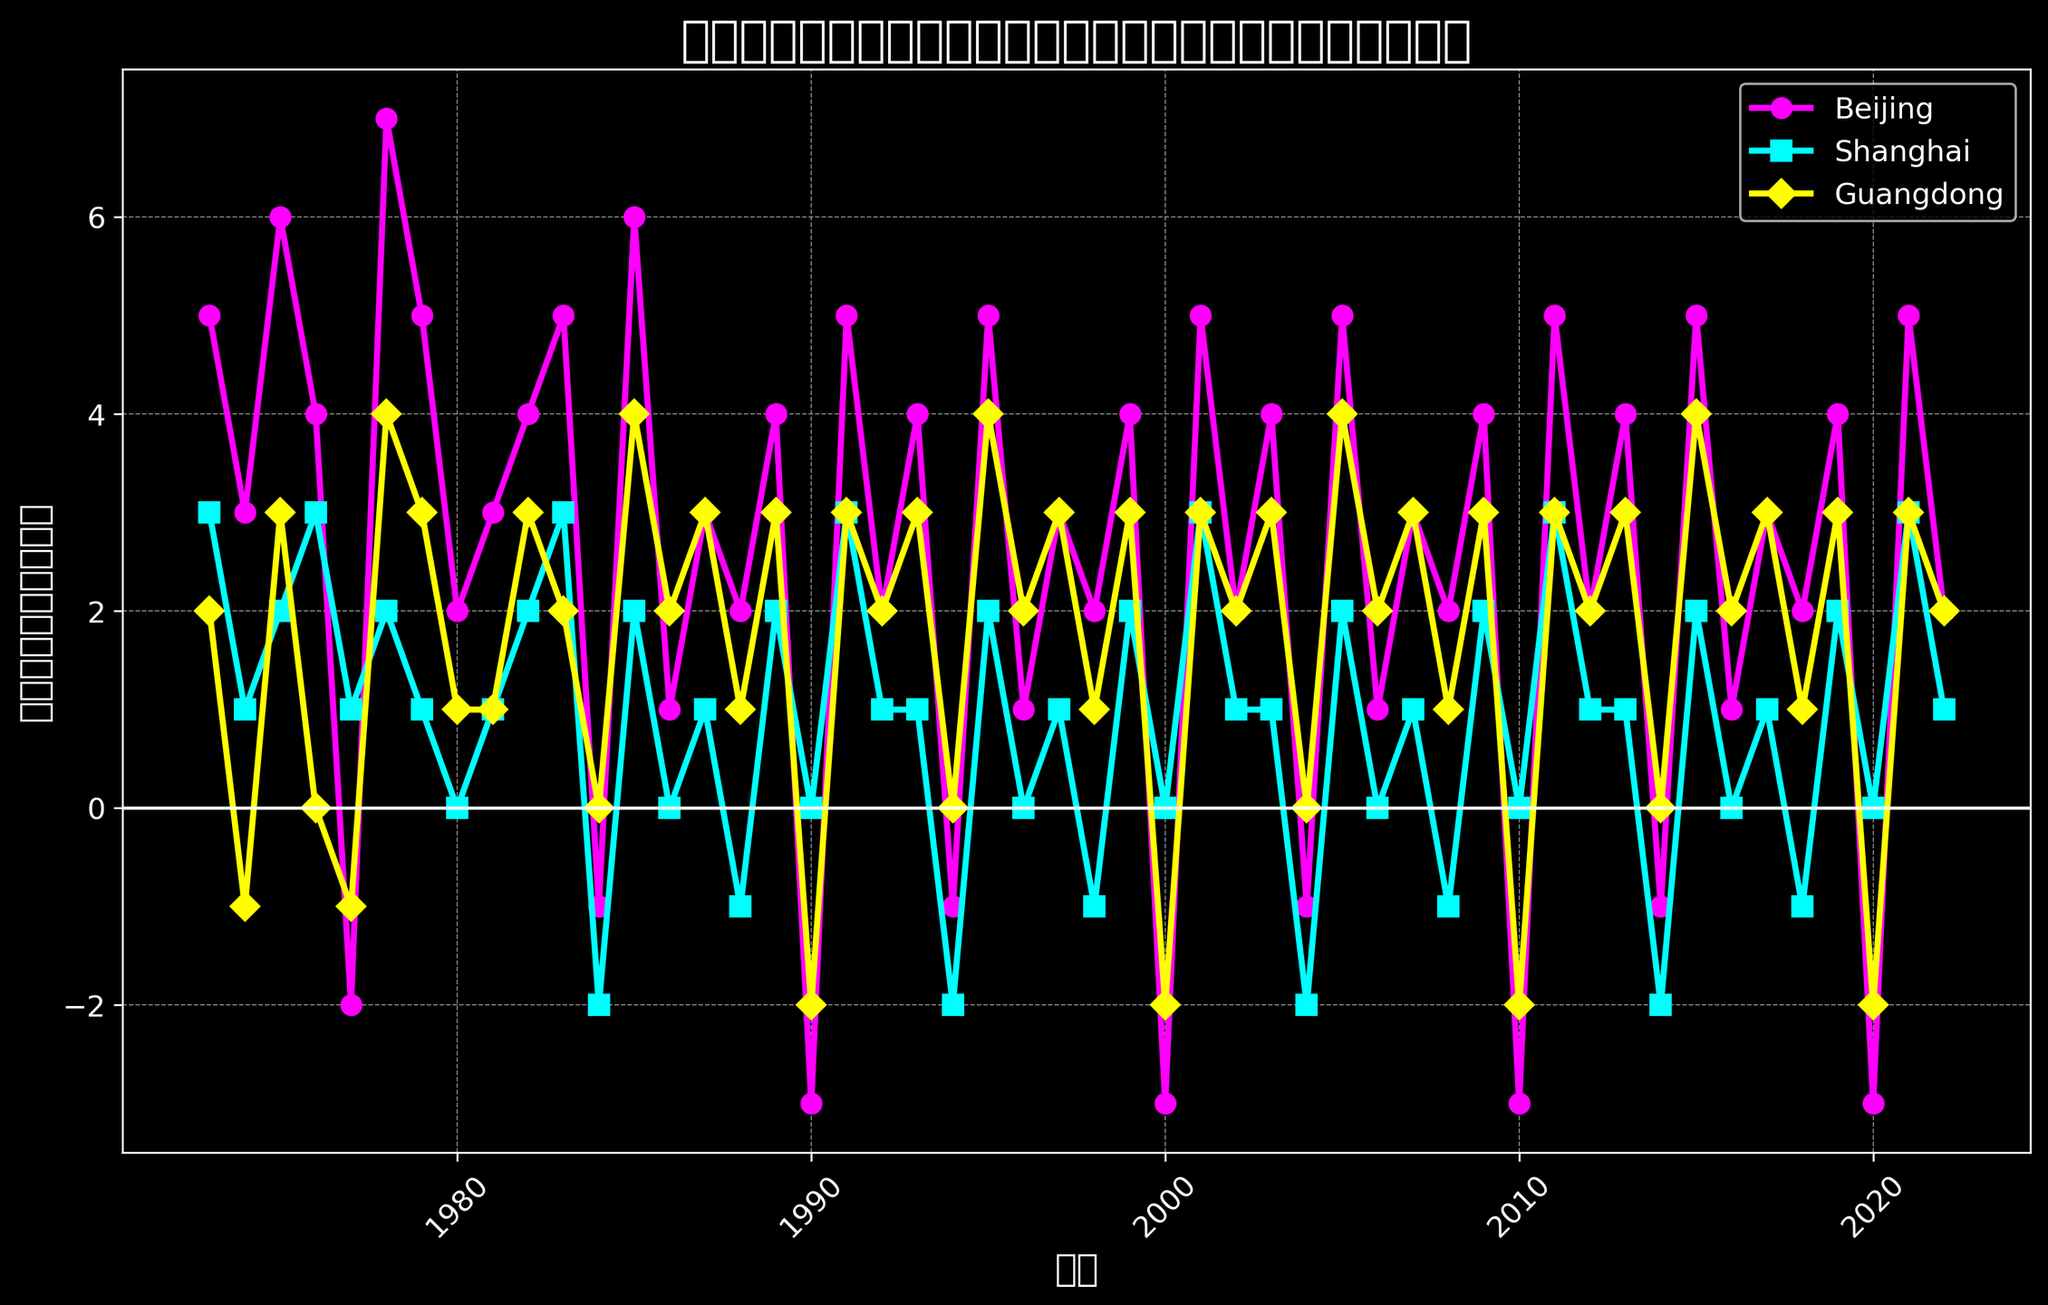What was the trend of research paper publications in Beijing during the 1980s? The trend can be determined by looking at the data points for Beijing during the 1980s. It shows fluctuations, with both dips and rises. Starting with a high value in 1981, there's a drop around mid-1980s, and another significant drop in 1990 before recovering again.
Answer: Fluctuating, with notable drops around mid-1980s and in 1990 Which province had the most stable number of research paper publications in the last decade? To determine stability, analyze the fluctuations in each province's data for the last decade (2013-2022). Beijing and Guangdong showed fluctuations, but Shanghai had the smallest changes in publication numbers over these years.
Answer: Shanghai During which year did all three provinces experience either zero or negative changes in research paper publications? By observing the points where all three lines are either at or below zero, check the data points for each year. The year 2010 shows all three provinces having zero or negative changes (Beijing: -3, Shanghai: 0, Guangdong: -2).
Answer: 2010 In which year did Beijing show the largest increase in research paper publications compared to the previous year? To find the year with the largest increase, look for the steepest upward slope in Beijing's line. The year 1978 to 1979 shows an increase from -2 in 1977 to 7 in 1978 and then 5 in 1979, indicating a steep rise.
Answer: 1977 to 1978 What are the colors used to represent each province, and what does each color signify? By looking at the legend or the colors of the lines in the figure, Beijing is represented by magenta, Shanghai by cyan, and Guangdong by yellow, identifying each province with a unique color.
Answer: Magenta for Beijing, cyan for Shanghai, yellow for Guangdong Which province had the highest research paper publications peak and in which year? Find the highest point for each province's line. Beijing's highest point is in 1978 with a value of 7, which is the highest among all peaks shown.
Answer: Beijing in 1978 From the visual pattern, which province showed the least frequent negative changes in publications? Negative changes are indicated by downward slopes below the zero line. Comparing the frequencies, Guangdong has fewer and smaller negative changes compared to Beijing and Shanghai.
Answer: Guangdong Between 1984 and 1985, which province had the most significant change in research paper publications? Calculate differences for each province between 1984 and 1985. Beijing increased from -1 to 6, which indicates a significant change.
Answer: Beijing Compare the average research paper changes for Shanghai in the 1970s and the 1980s. Calculate the average publication changes for Shanghai. For the 1970s: (3+1+2+3+1+2+1+1)/8 = 1.75. For the 1980s: (0+1+2+3-2+2+0+1-1+2)/10 = 0.8. Comparing the two, the average is higher in the 1970s.
Answer: Higher in the 1970s (1.75 vs 0.8) Which year marked the start of a continuous increase in research papers for Guangdong after a significant drop? Look for a significant drop followed by consecutive increases. The year following the 1990 drop (-2) shows continuous increases from 1991 (3), indicating a recovery trend.
Answer: 1991 